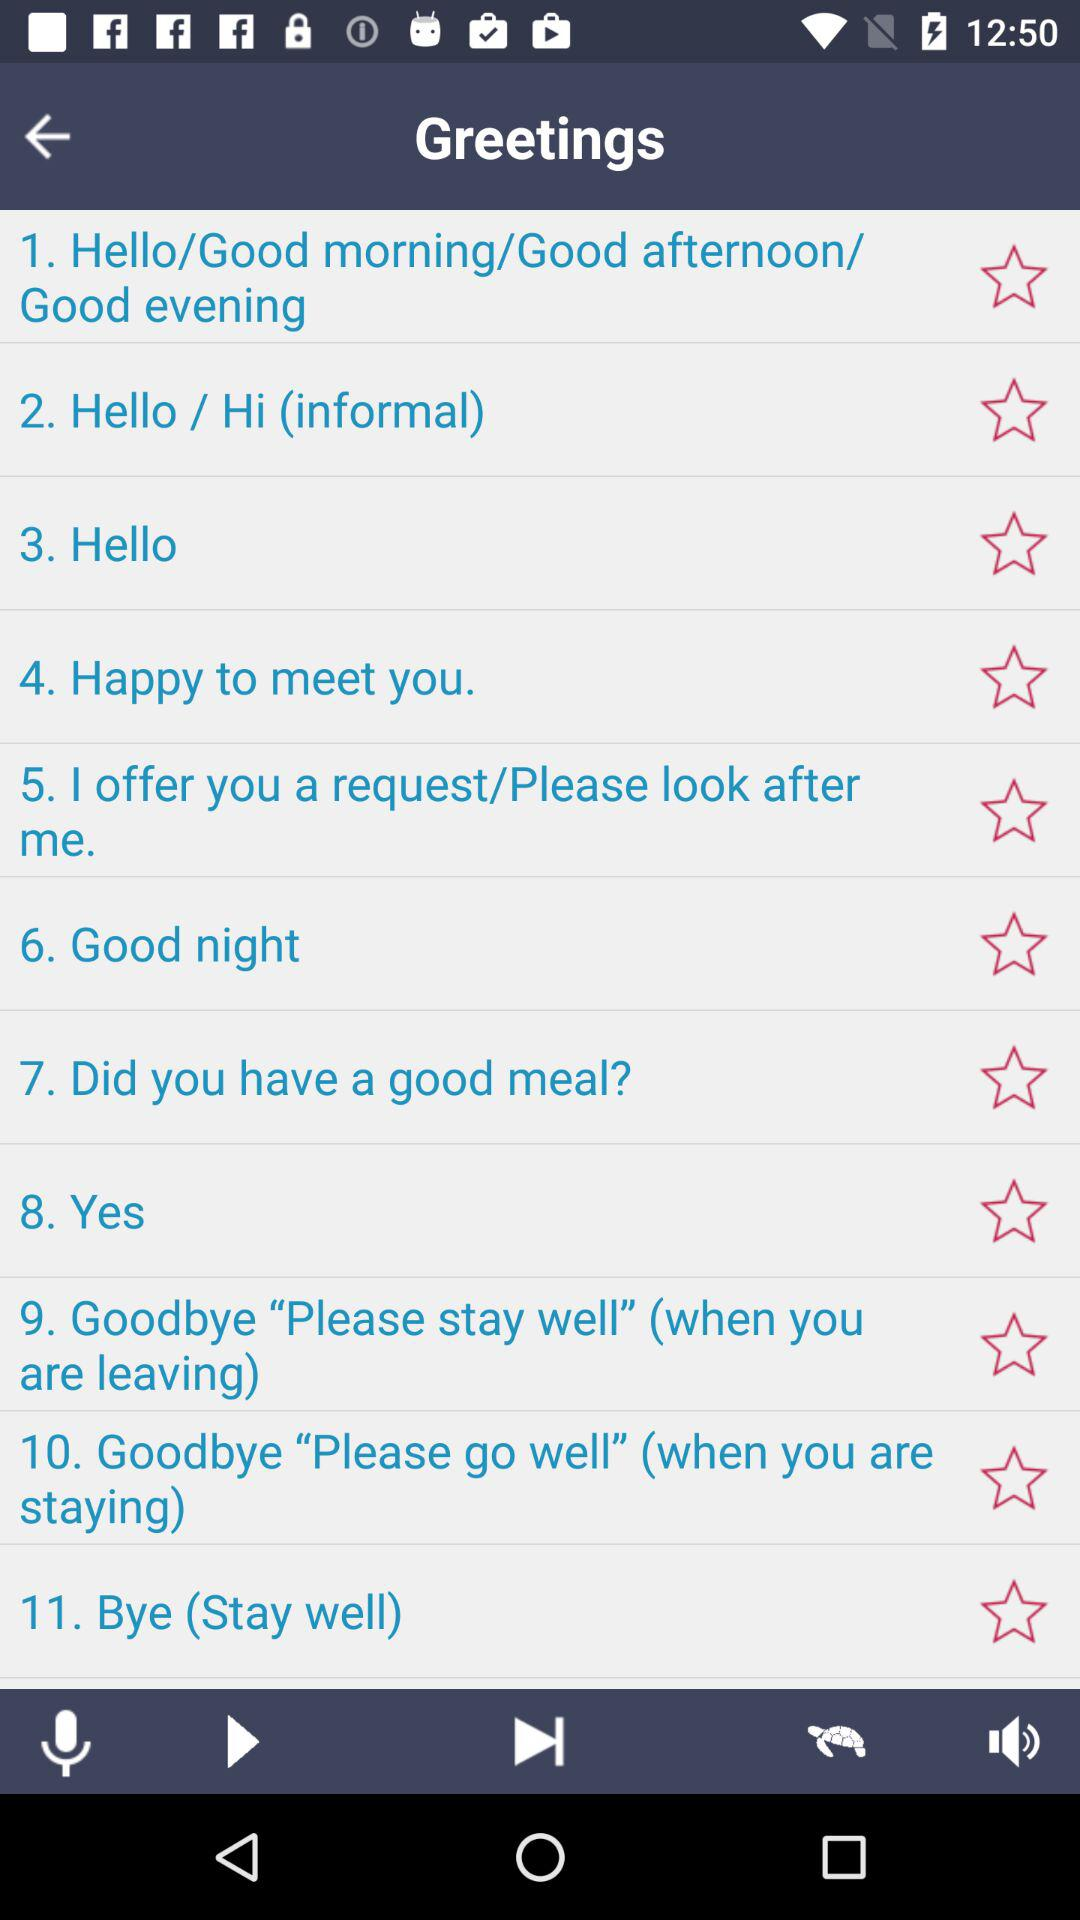How long is the third greeting?
When the provided information is insufficient, respond with <no answer>. <no answer> 